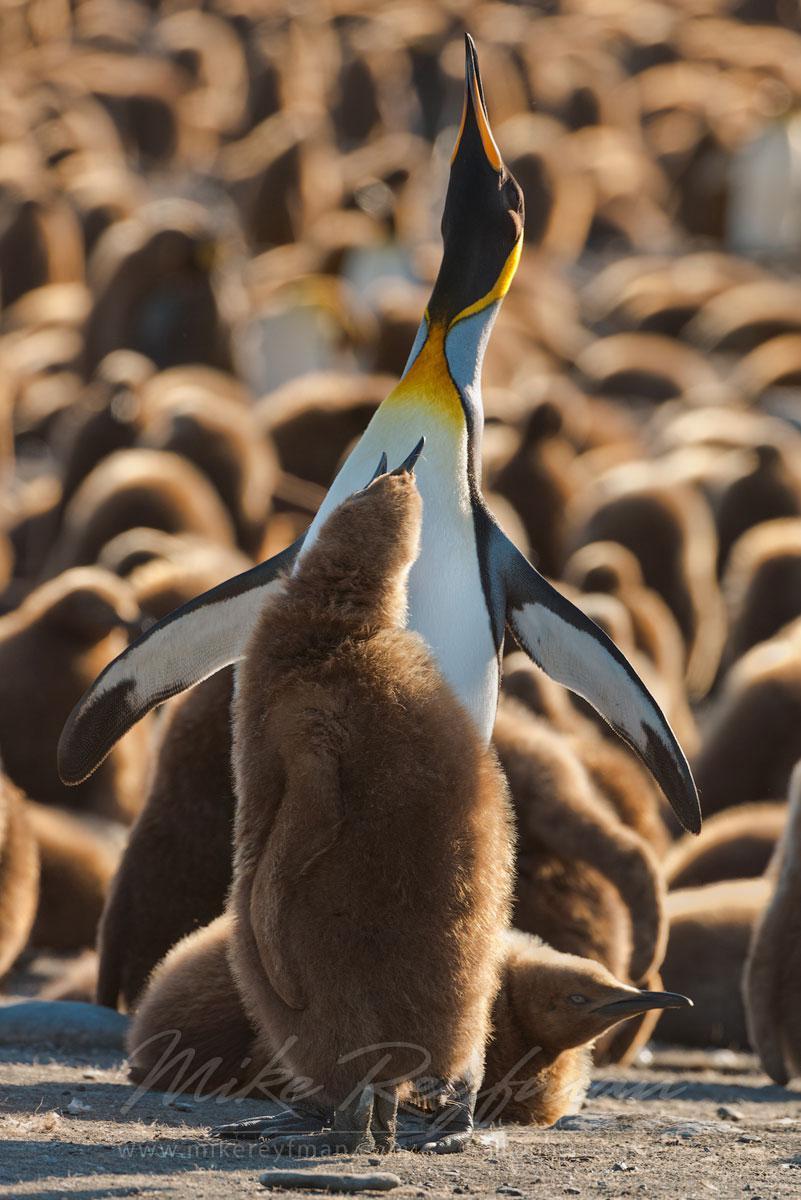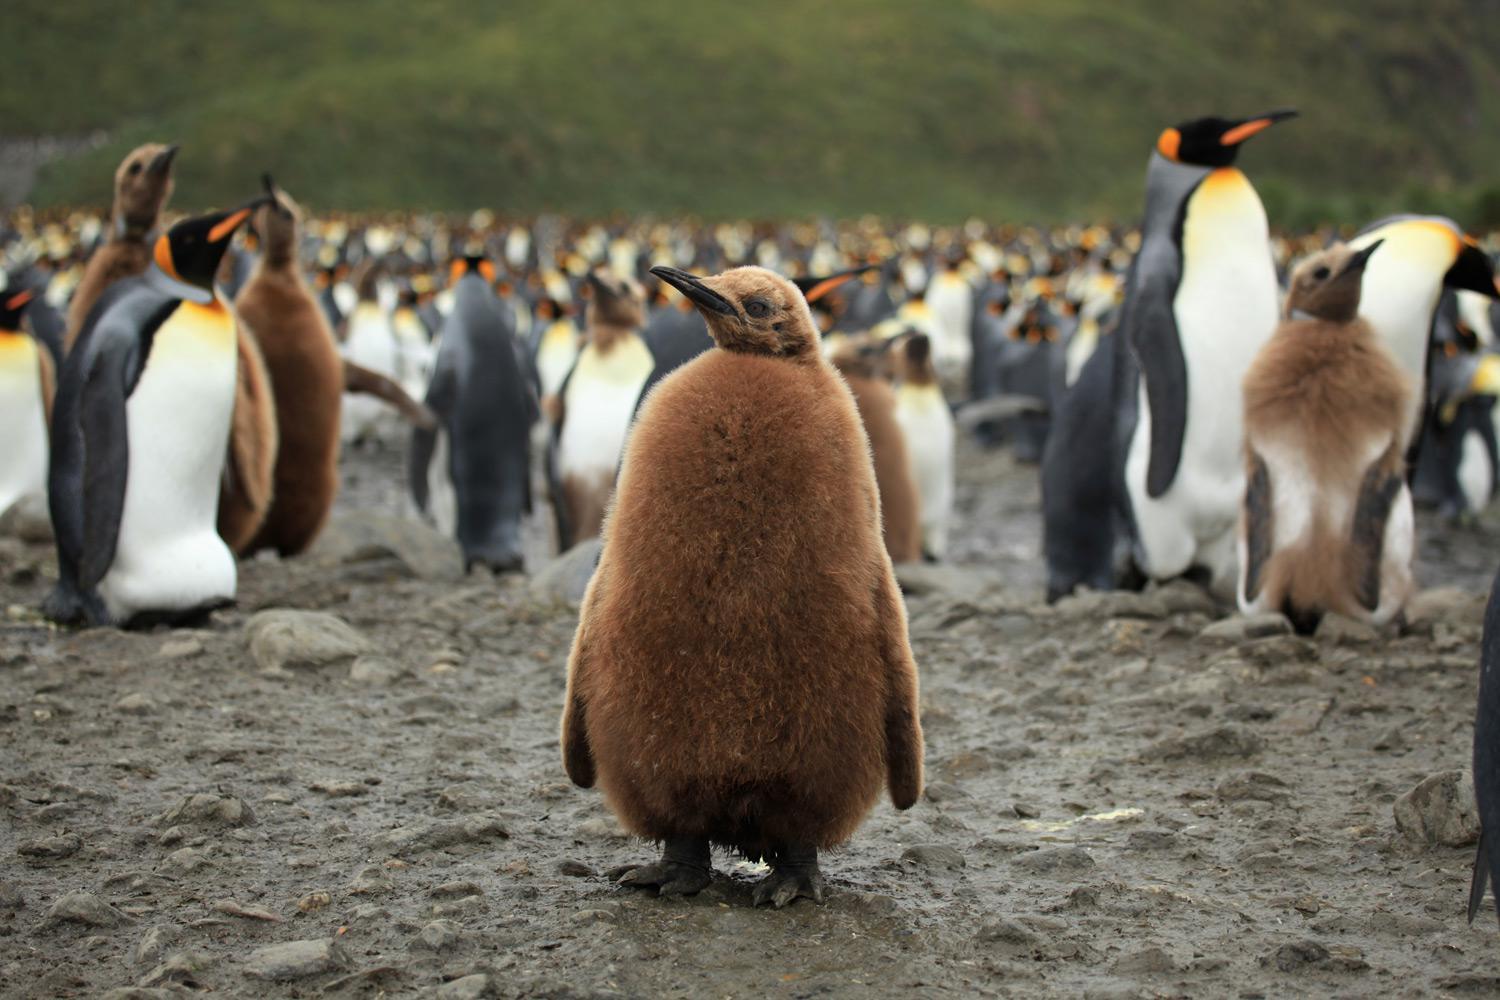The first image is the image on the left, the second image is the image on the right. Examine the images to the left and right. Is the description "There is one king penguin and one brown furry penguin in the right image." accurate? Answer yes or no. No. The first image is the image on the left, the second image is the image on the right. For the images shown, is this caption "There is exactly two penguins in the right image." true? Answer yes or no. No. 